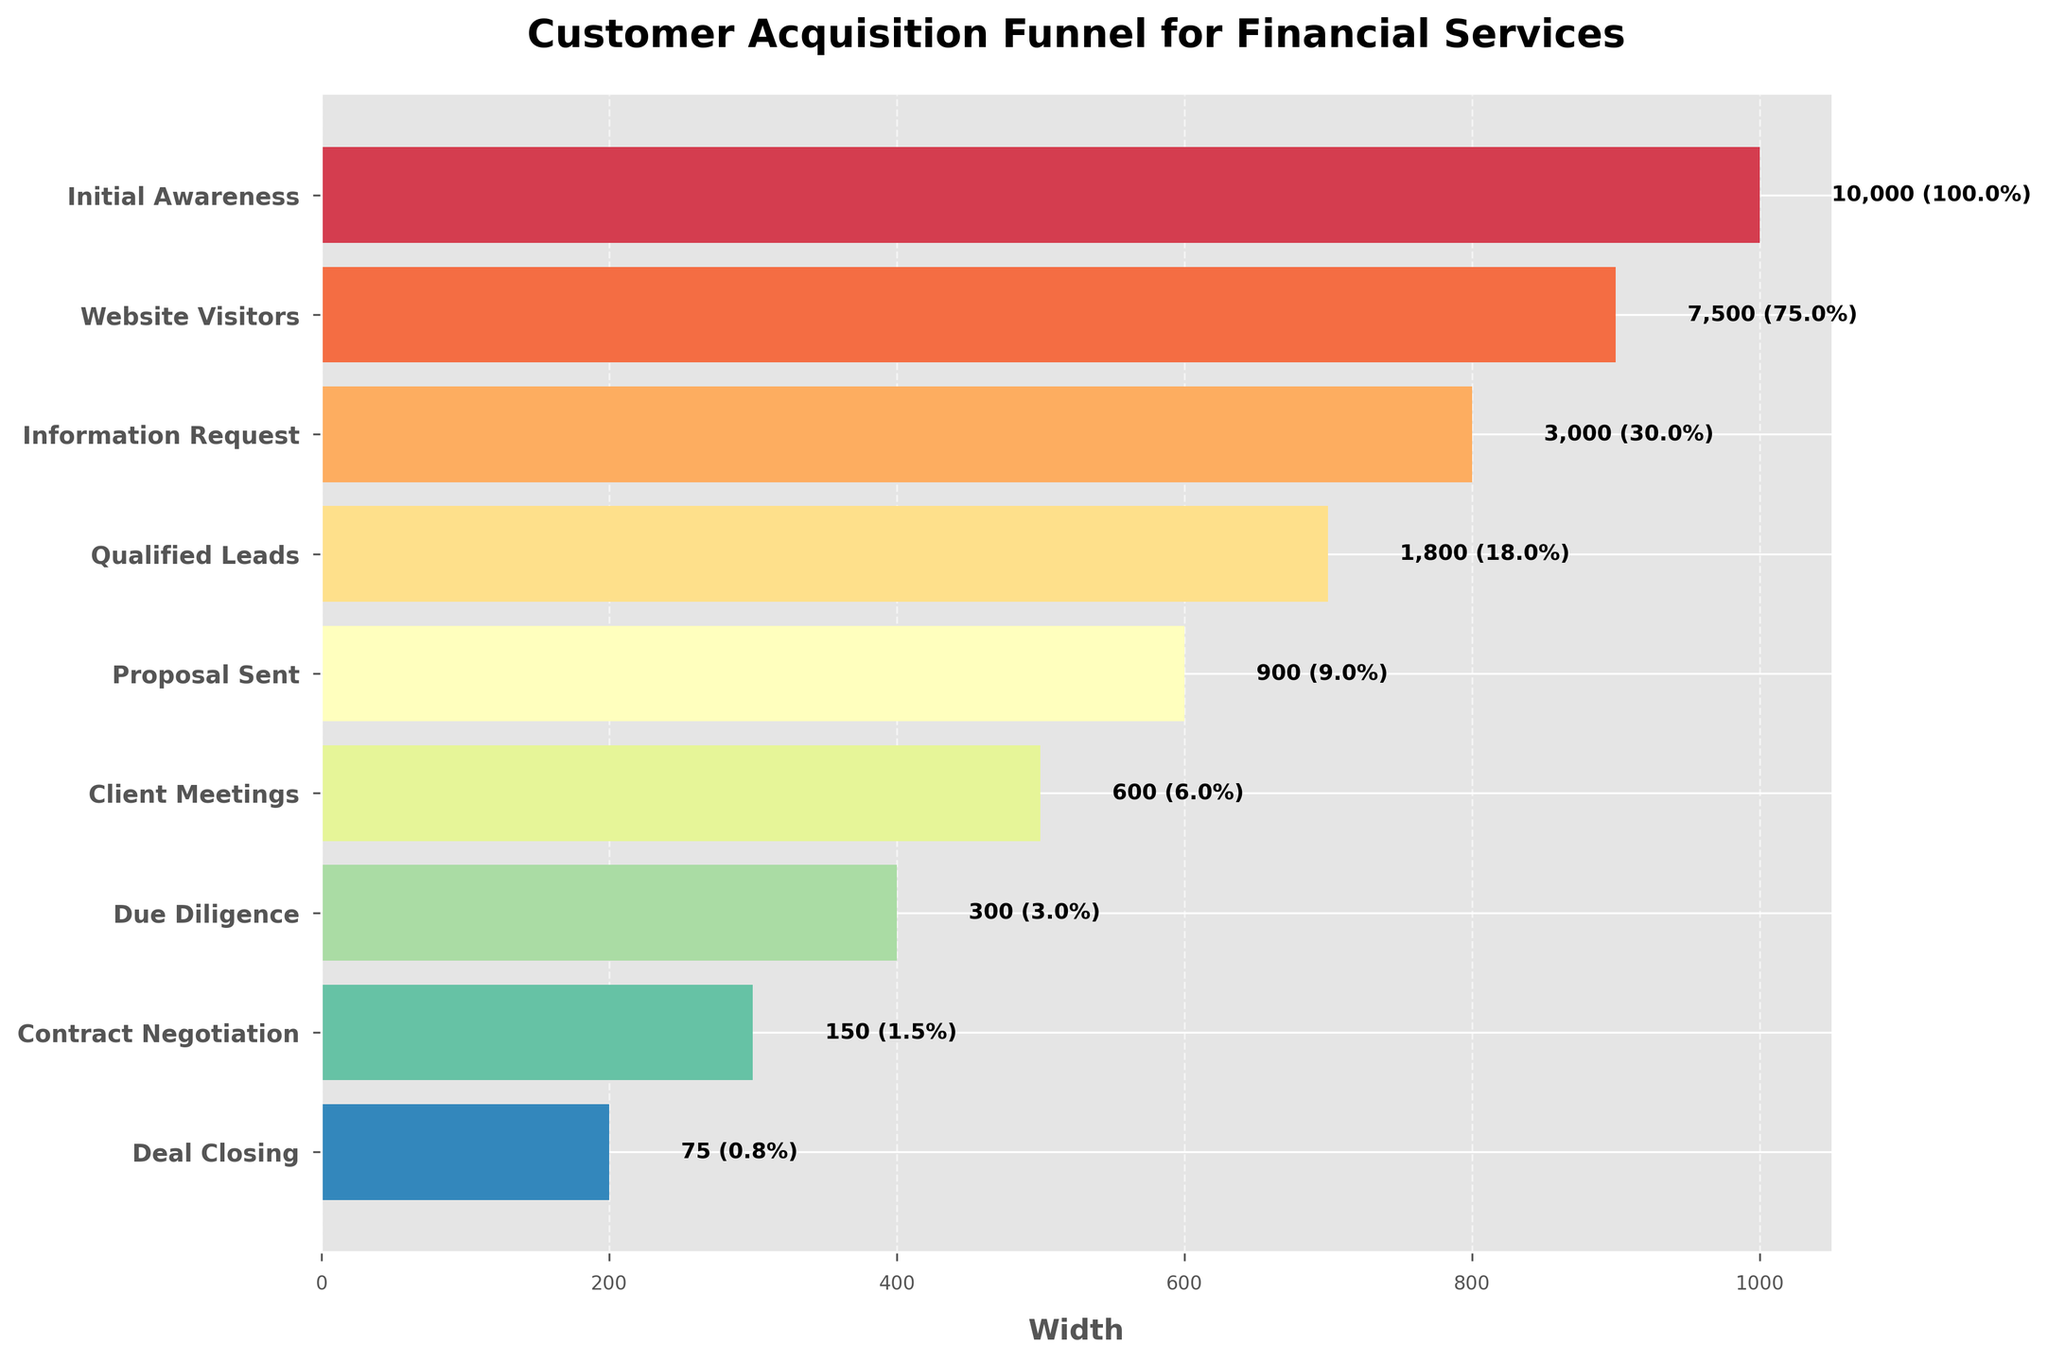What's the title of the funnel chart? The title of the funnel chart is written at the top of the figure.
Answer: Customer Acquisition Funnel for Financial Services How many stages are represented in the funnel? Count the number of bars or stages in the funnel chart from top to bottom.
Answer: 9 What is the percentage of website visitors compared to initial awareness? The number of website visitors is 7500 and the initial awareness is 10000. The percentage is calculated as (7500 / 10000) * 100.
Answer: 75% How many prospects are there at the 'Proposal Sent' stage? Find the 'Proposal Sent' stage on the y-axis and read the corresponding value from the chart.
Answer: 900 What is the difference in the number of prospects between the 'Qualified Leads' and 'Client Meetings' stages? The number of prospects in the 'Qualified Leads' stage is 1800, and in the 'Client Meetings' stage is 600. The difference is calculated as 1800 - 600.
Answer: 1200 At which stage does the number of prospects drop below 1000? Check each stage from top to bottom and find the first one where the number is below 1000.
Answer: Proposal Sent What is the ratio of 'Deal Closing' to 'Due Diligence' in terms of prospects? The number of prospects in the 'Deal Closing' stage is 75, and in the 'Due Diligence' stage is 300. The ratio is 75 / 300.
Answer: 1:4 Which stage has the largest percentage drop in prospects from the previous stage? Calculate the percentage drop for each stage by comparing the number of prospects to the previous stage. Identify the stage with the highest percentage drop.
Answer: Information Request to Qualified Leads What is the cumulative percentage from 'Initial Awareness' to 'Client Meetings'? Add the percentages from 'Initial Awareness' to 'Client Meetings'. The stages are Initial Awareness (100%), Website Visitors (75%), Information Request (30%), Qualified Leads (18%), Proposal Sent (9%), Client Meetings (6%). Sum up: 100% + 75% + 30% + 18% + 9% + 6%. The cumulative percentage is not straightforward but should consider as is.
Answer: 238% How does the bar width change as you move down the funnel? Observe the width of the bars from the top to the bottom of the funnel chart.
Answer: It decreases 